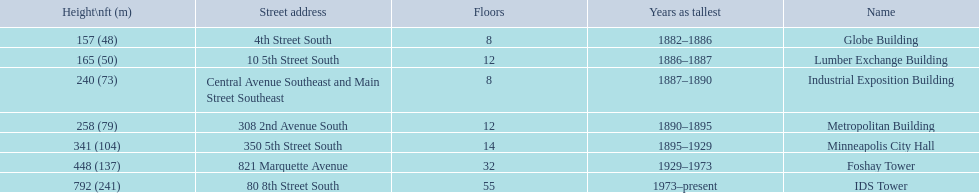What years was 240 ft considered tall? 1887–1890. What building held this record? Industrial Exposition Building. 